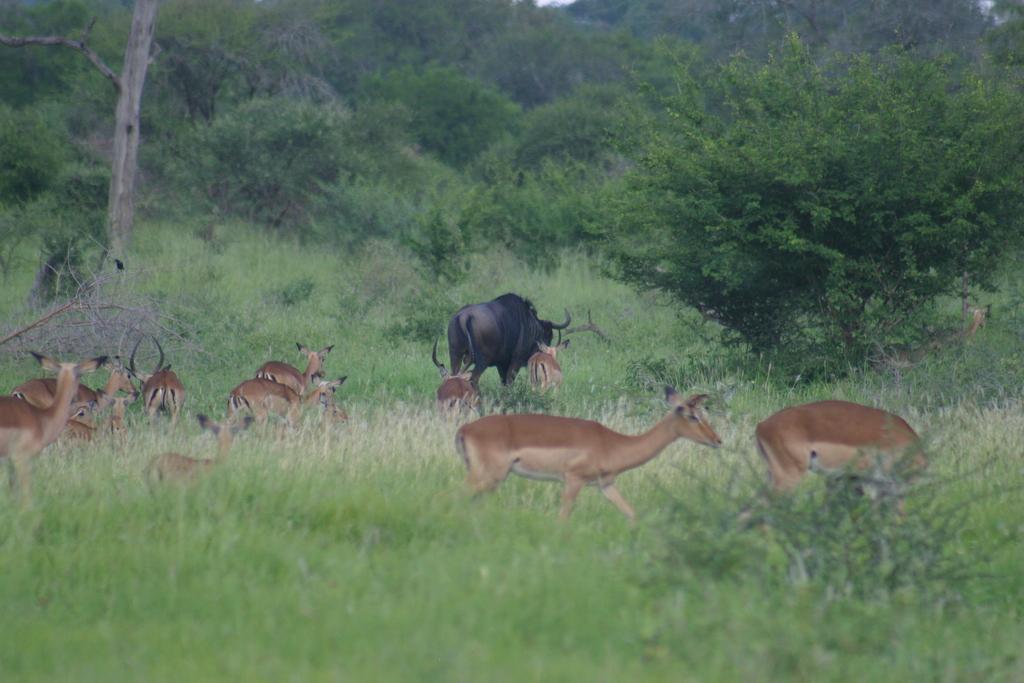Could you give a brief overview of what you see in this image? This picture is clicked outside the city. In the foreground we can see the green grass. In the center there is a herd seems to be running on the ground. In the background there is a black color animal seems to be running on the ground and we can see the plants and trees. 